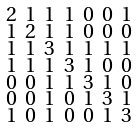<formula> <loc_0><loc_0><loc_500><loc_500>\begin{smallmatrix} 2 & 1 & 1 & 1 & 0 & 0 & 1 \\ 1 & 2 & 1 & 1 & 0 & 0 & 0 \\ 1 & 1 & 3 & 1 & 1 & 1 & 1 \\ 1 & 1 & 1 & 3 & 1 & 0 & 0 \\ 0 & 0 & 1 & 1 & 3 & 1 & 0 \\ 0 & 0 & 1 & 0 & 1 & 3 & 1 \\ 1 & 0 & 1 & 0 & 0 & 1 & 3 \end{smallmatrix}</formula> 